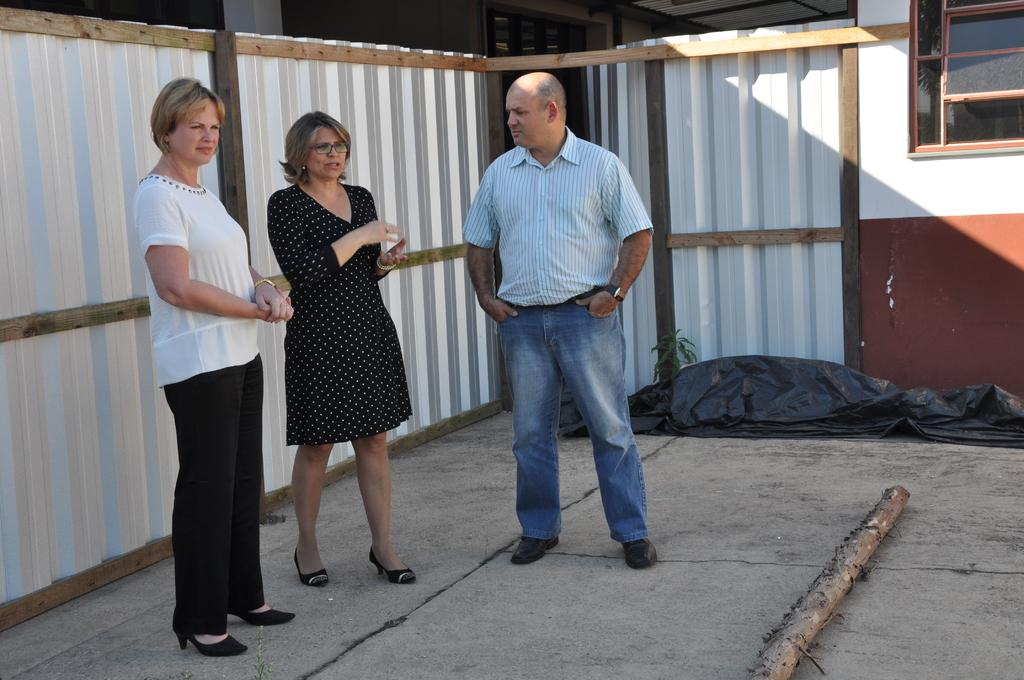What can be seen in the image involving human presence? There are people standing in the image. What type of structure is visible in the image? There is a building in the image. What is covering something in the image? There is a cover in the image. What is on the ground in the image? There is a wooden pole on the ground in the image. What type of yard is visible in the image? There is no yard visible in the image. How many planes can be seen flying in the image? There are no planes present in the image. 